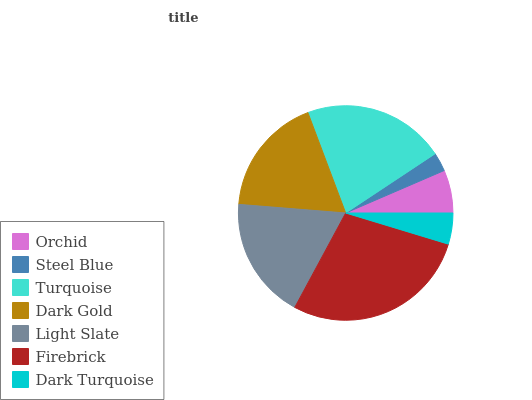Is Steel Blue the minimum?
Answer yes or no. Yes. Is Firebrick the maximum?
Answer yes or no. Yes. Is Turquoise the minimum?
Answer yes or no. No. Is Turquoise the maximum?
Answer yes or no. No. Is Turquoise greater than Steel Blue?
Answer yes or no. Yes. Is Steel Blue less than Turquoise?
Answer yes or no. Yes. Is Steel Blue greater than Turquoise?
Answer yes or no. No. Is Turquoise less than Steel Blue?
Answer yes or no. No. Is Dark Gold the high median?
Answer yes or no. Yes. Is Dark Gold the low median?
Answer yes or no. Yes. Is Light Slate the high median?
Answer yes or no. No. Is Firebrick the low median?
Answer yes or no. No. 